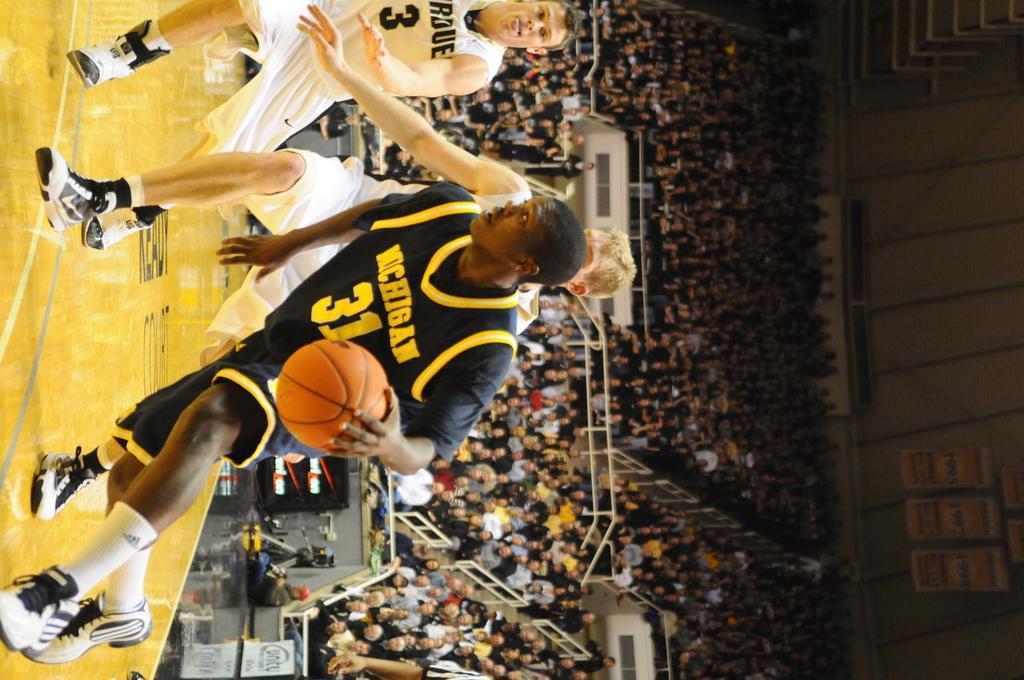Describe this image in one or two sentences. In this picture we can see three men running on the ground where a man holding a ball with his hand and in the background we can see a group of people sitting, banners. 